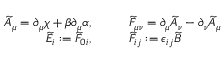Convert formula to latex. <formula><loc_0><loc_0><loc_500><loc_500>\begin{array} { r l } { \widetilde { A } _ { \mu } = \partial _ { \mu } \chi + \beta \partial _ { \mu } \alpha , } & { \quad \widetilde { F } _ { \mu \nu } = \partial _ { \mu } \widetilde { A } _ { \nu } - \partial _ { \nu } \widetilde { A } _ { \mu } } \\ { \widetilde { E } _ { i } \colon = \widetilde { F } _ { 0 i } , } & { \quad \widetilde { F } _ { i j } \colon = \epsilon _ { i j } \widetilde { B } } \end{array}</formula> 